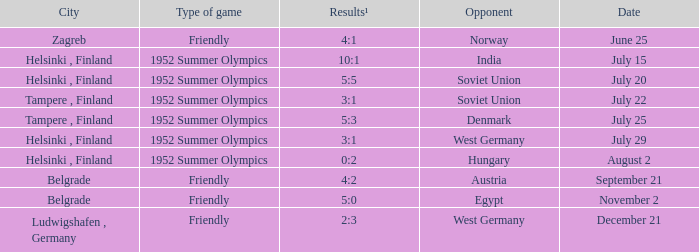What Type of game has a Results¹ of 10:1? 1952 Summer Olympics. 